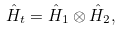<formula> <loc_0><loc_0><loc_500><loc_500>\hat { H } _ { t } = \hat { H } _ { 1 } \otimes \hat { H } _ { 2 } ,</formula> 